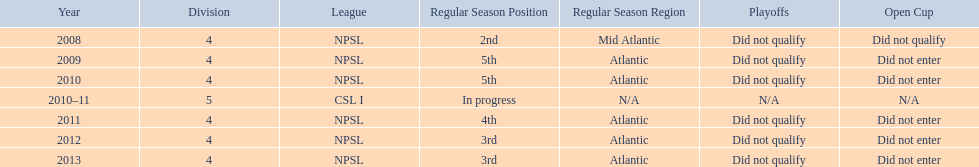What are the leagues? NPSL, NPSL, NPSL, CSL I, NPSL, NPSL, NPSL. Of these, what league is not npsl? CSL I. 